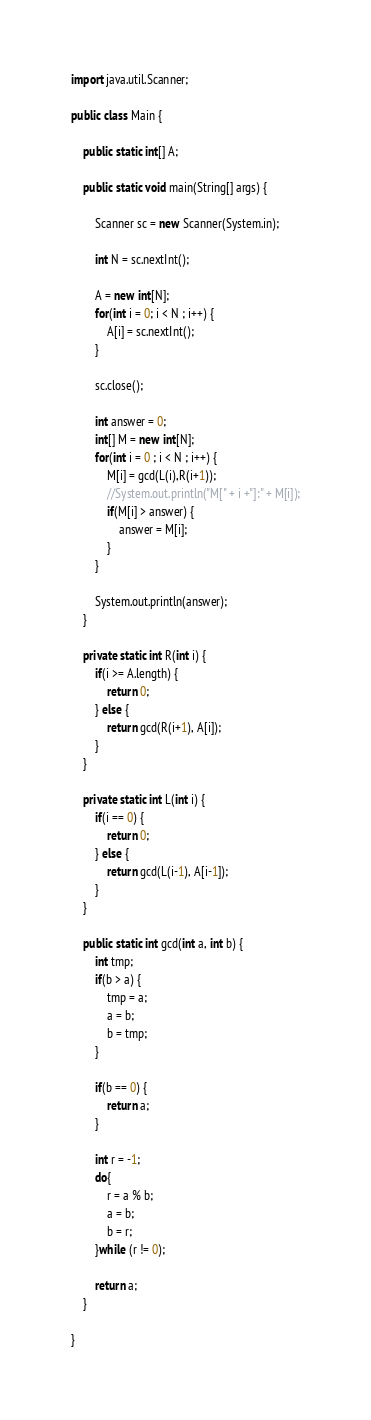<code> <loc_0><loc_0><loc_500><loc_500><_Java_>import java.util.Scanner;

public class Main {

	public static int[] A;

	public static void main(String[] args) {

		Scanner sc = new Scanner(System.in);

		int N = sc.nextInt();

		A = new int[N];
		for(int i = 0; i < N ; i++) {
			A[i] = sc.nextInt();
		}

		sc.close();

		int answer = 0;
		int[] M = new int[N];
		for(int i = 0 ; i < N ; i++) {
			M[i] = gcd(L(i),R(i+1));
			//System.out.println("M[" + i +"]:" + M[i]);
			if(M[i] > answer) {
				answer = M[i];
			}
		}

		System.out.println(answer);
	}

	private static int R(int i) {
		if(i >= A.length) {
			return 0;
		} else {
			return gcd(R(i+1), A[i]);
		}
	}

	private static int L(int i) {
		if(i == 0) {
			return 0;
		} else {
			return gcd(L(i-1), A[i-1]);
		}
	}

	public static int gcd(int a, int b) {
		int tmp;
		if(b > a) {
			tmp = a;
			a = b;
			b = tmp;
		}

		if(b == 0) {
			return a;
		}

	    int r = -1;
	    do{
	        r = a % b;
	        a = b;
	        b = r;
	    }while (r != 0);

	    return a;
	}

}
</code> 